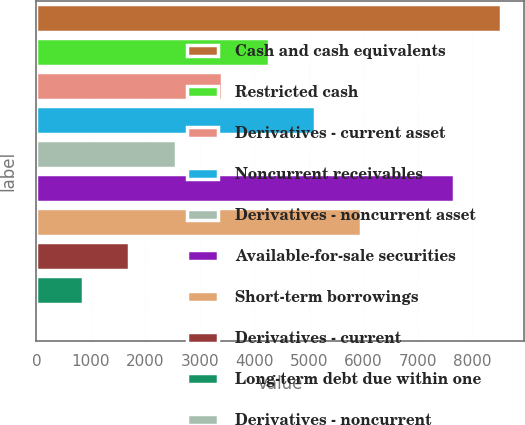Convert chart. <chart><loc_0><loc_0><loc_500><loc_500><bar_chart><fcel>Cash and cash equivalents<fcel>Restricted cash<fcel>Derivatives - current asset<fcel>Noncurrent receivables<fcel>Derivatives - noncurrent asset<fcel>Available-for-sale securities<fcel>Short-term borrowings<fcel>Derivatives - current<fcel>Long-term debt due within one<fcel>Derivatives - noncurrent<nl><fcel>8519<fcel>4261<fcel>3409.4<fcel>5112.6<fcel>2557.8<fcel>7667.4<fcel>5964.2<fcel>1706.2<fcel>854.6<fcel>3<nl></chart> 